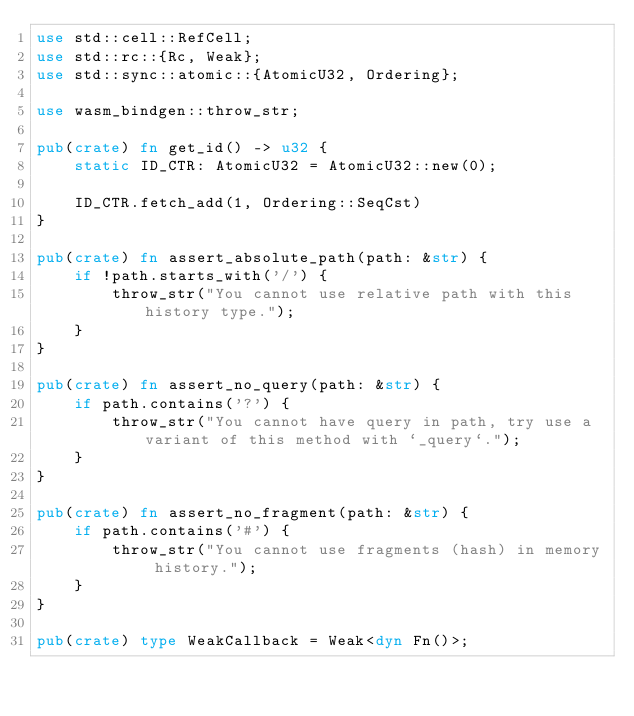<code> <loc_0><loc_0><loc_500><loc_500><_Rust_>use std::cell::RefCell;
use std::rc::{Rc, Weak};
use std::sync::atomic::{AtomicU32, Ordering};

use wasm_bindgen::throw_str;

pub(crate) fn get_id() -> u32 {
    static ID_CTR: AtomicU32 = AtomicU32::new(0);

    ID_CTR.fetch_add(1, Ordering::SeqCst)
}

pub(crate) fn assert_absolute_path(path: &str) {
    if !path.starts_with('/') {
        throw_str("You cannot use relative path with this history type.");
    }
}

pub(crate) fn assert_no_query(path: &str) {
    if path.contains('?') {
        throw_str("You cannot have query in path, try use a variant of this method with `_query`.");
    }
}

pub(crate) fn assert_no_fragment(path: &str) {
    if path.contains('#') {
        throw_str("You cannot use fragments (hash) in memory history.");
    }
}

pub(crate) type WeakCallback = Weak<dyn Fn()>;
</code> 